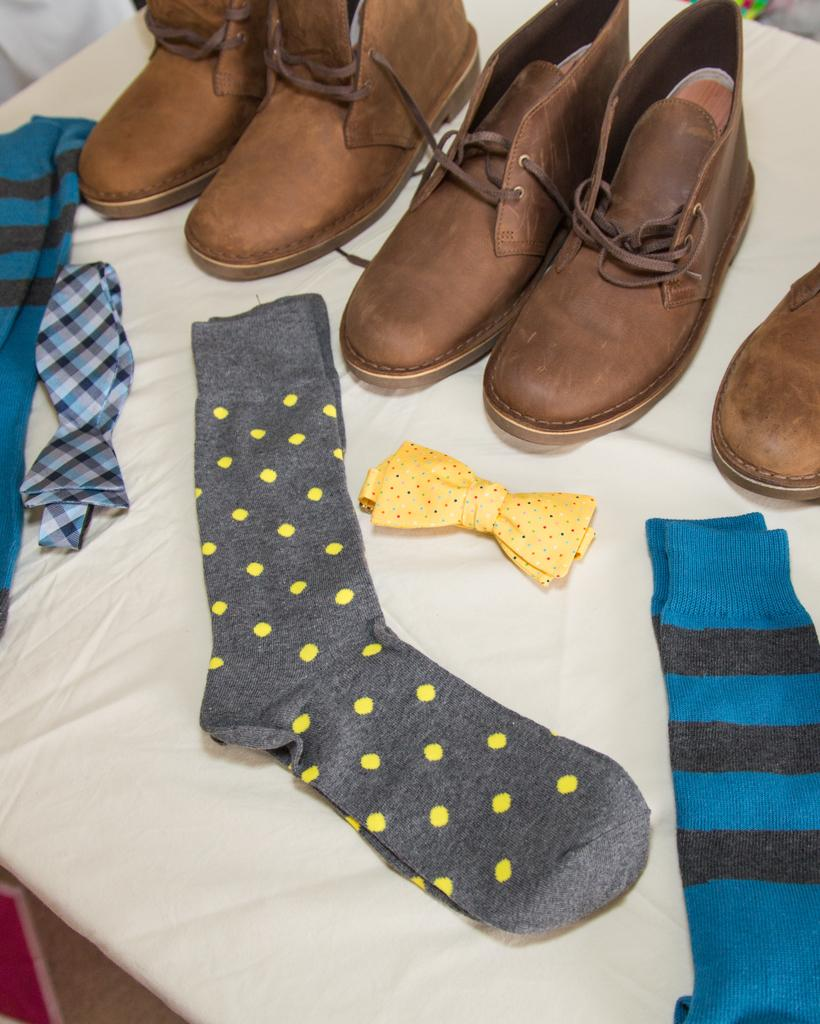What type of clothing accessory is in the image? There is a bow tie in the image. What other clothing items can be seen in the image? There are socks and shoes visible in the image. On what surface are the items placed? The items are placed on a white cloth. Where is the garden located in the image? There is no garden present in the image. What type of collar is featured on the shirt in the image? There is no shirt or collar present in the image. 